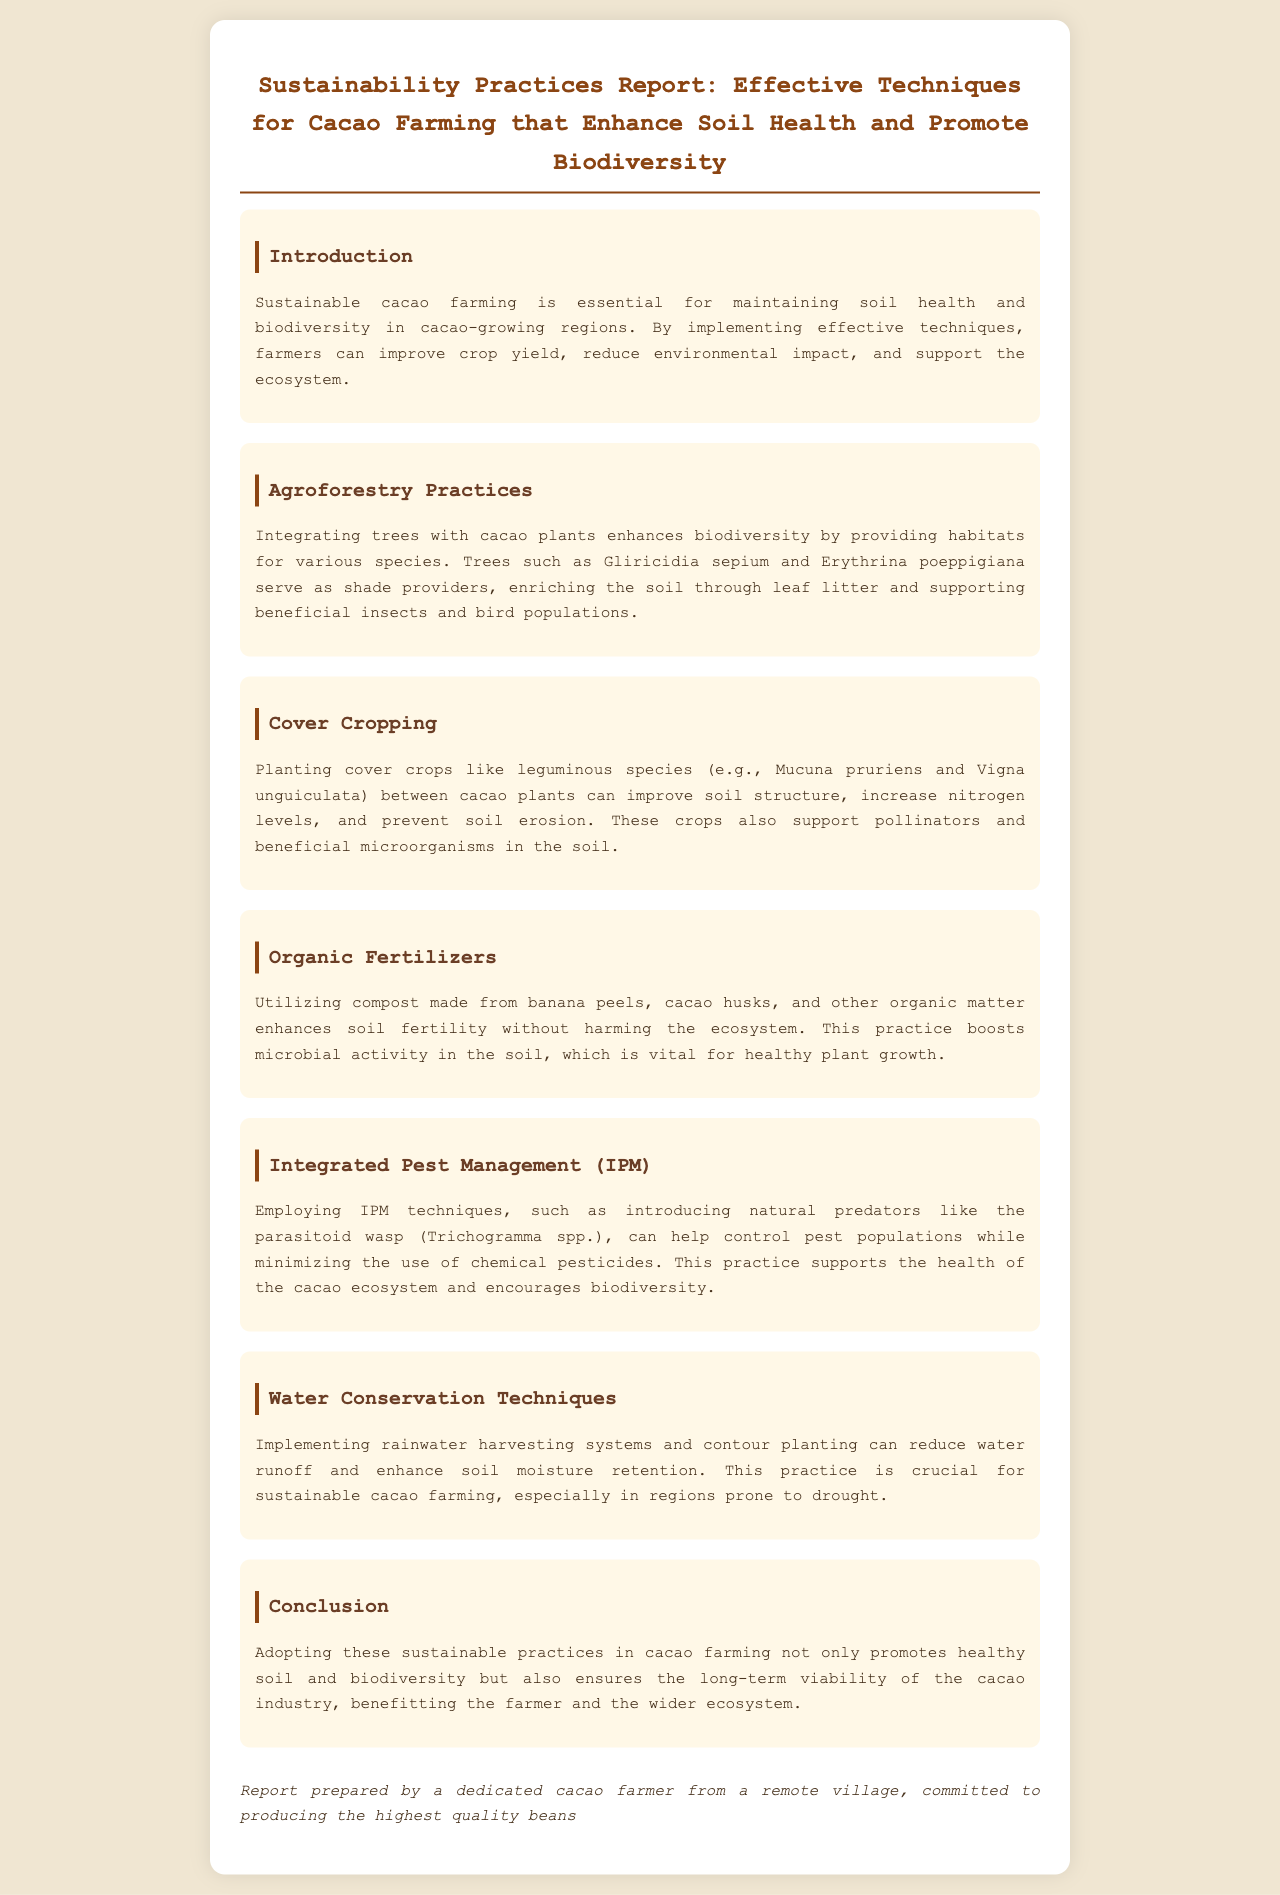What is the main focus of the report? The main focus of the report is outlined in the introduction, emphasizing sustainable cacao farming that enhances soil health and promotes biodiversity.
Answer: Sustainable cacao farming Which cover crops are mentioned in the document? The document lists specific leguminous species as cover crops that improve soil structure and nitrogen levels.
Answer: Mucuna pruriens and Vigna unguiculata What is one organic matter used for compost? The report provides examples of materials to make compost that enhance soil fertility without harming the ecosystem.
Answer: Cacao husks What technique helps control pest populations naturally? The document discusses a specific method that introduces natural predators as part of pest management.
Answer: Integrated Pest Management (IPM) How does agroforestry benefit cacao farming? The document explains the benefits of integrating trees with cacao plants and their impact on biodiversity.
Answer: Provides habitats for various species 